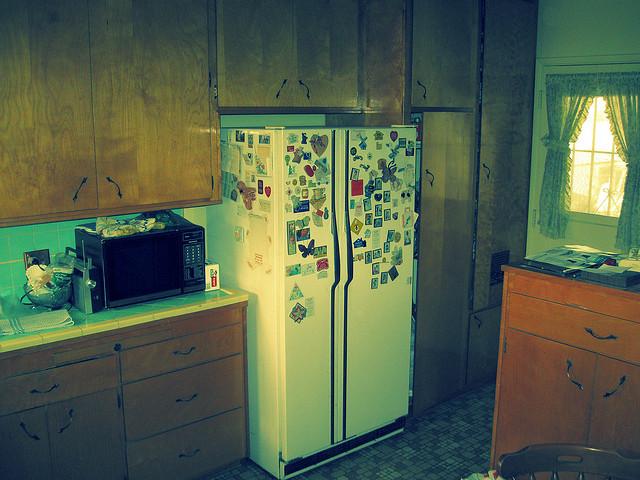What color is the refrigerator?
Write a very short answer. White. What page from the newspaper has been tacked to the wall?
Give a very brief answer. None. Is this an updated kitchen?
Quick response, please. No. What room is this?
Short answer required. Kitchen. What is on top of the fridge not being used?
Keep it brief. Cabinet. What is the dominant color?
Give a very brief answer. Brown. How many forks are visible?
Give a very brief answer. 0. How many pans sit atop the stove?
Quick response, please. 0. What is on the refrigerator?
Answer briefly. Magnets. What color are the cabinets?
Keep it brief. Brown. If the brown cabinet missing a door?
Be succinct. No. What color is the microwave?
Quick response, please. Black. 